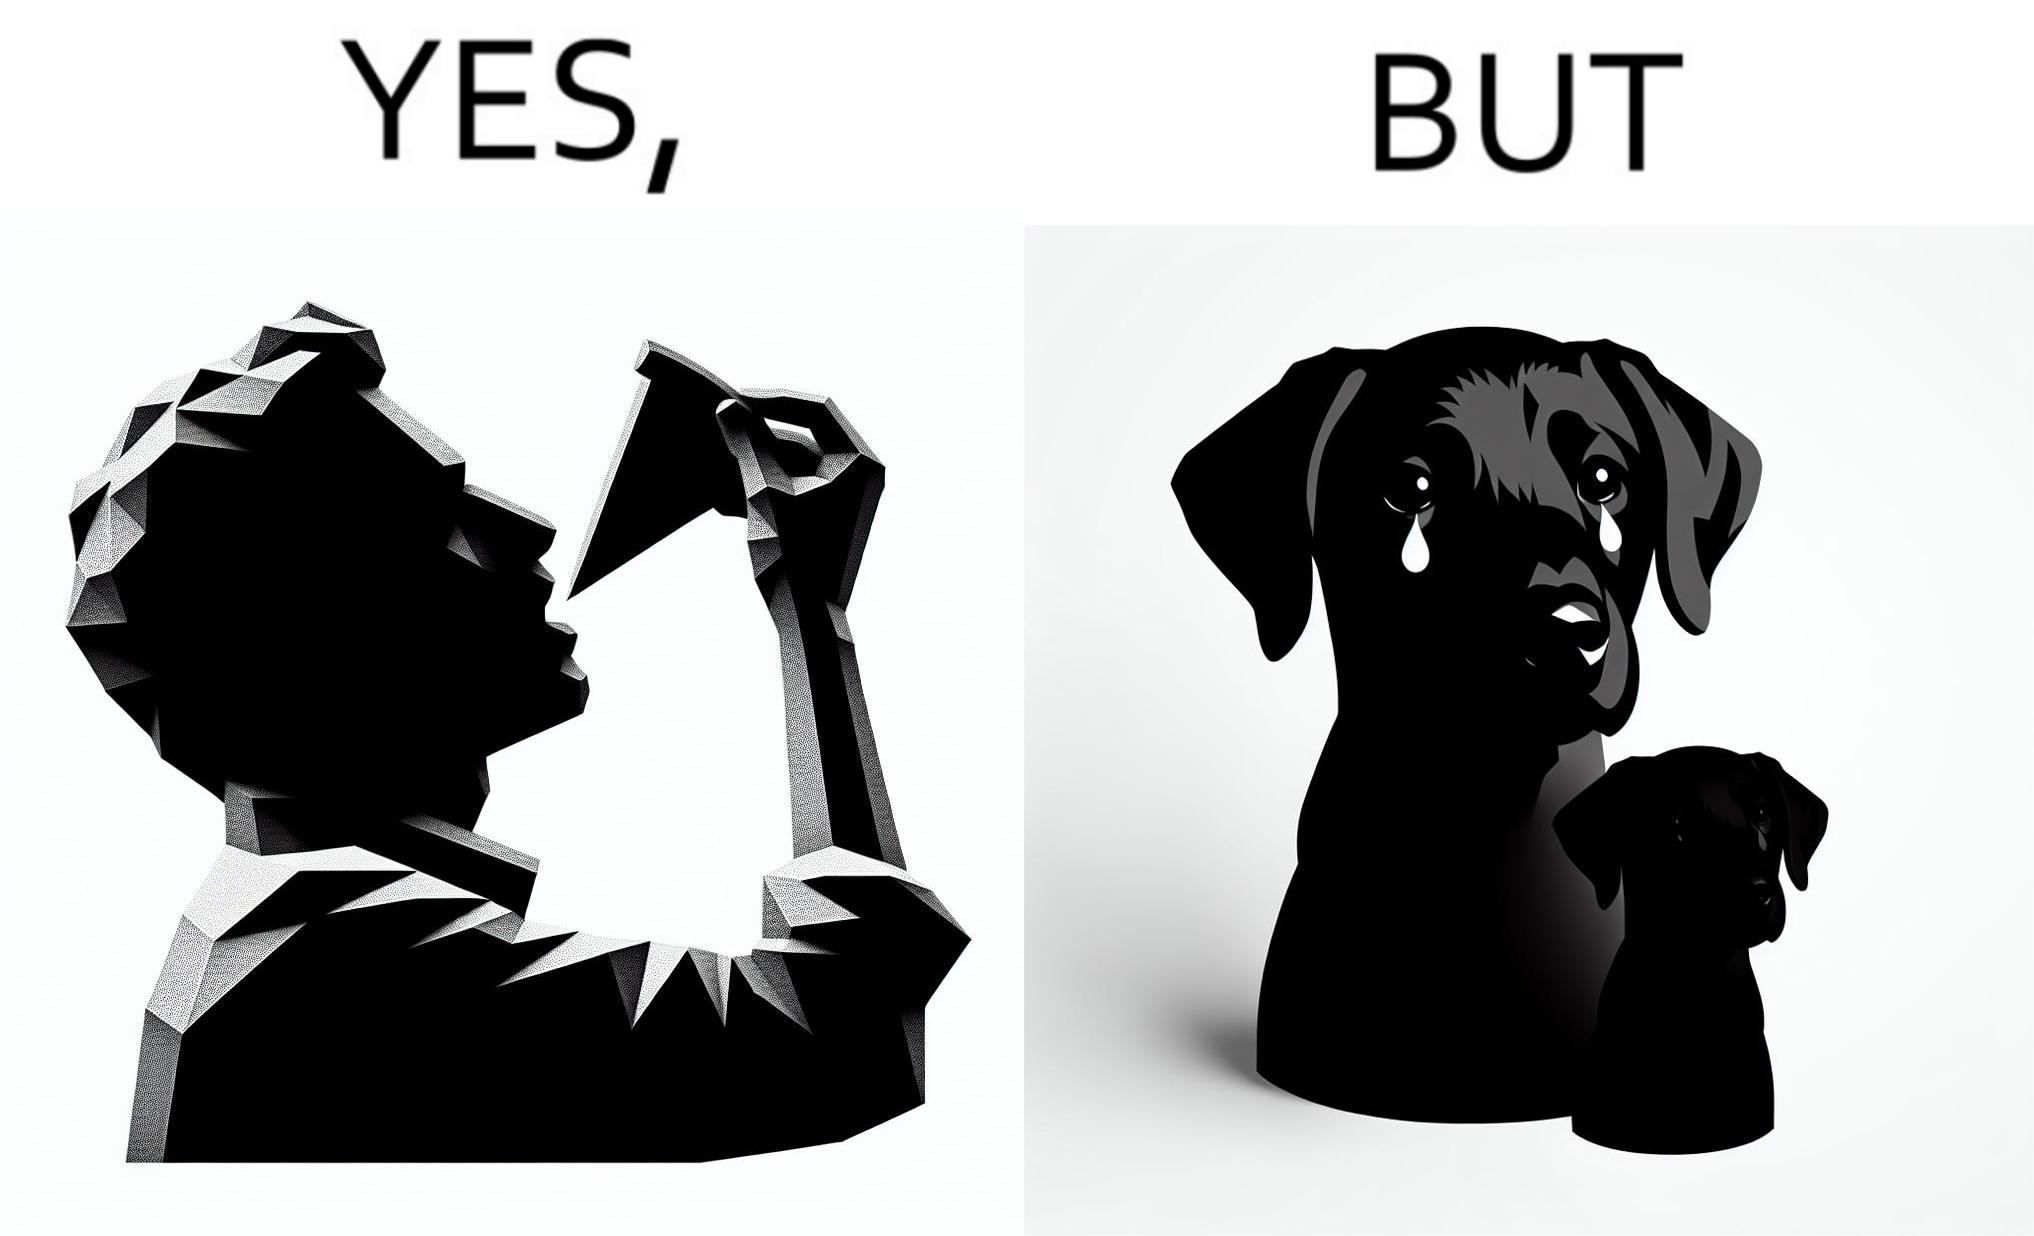Would you classify this image as satirical? Yes, this image is satirical. 